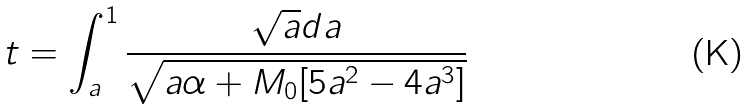<formula> <loc_0><loc_0><loc_500><loc_500>t = \int _ { a } ^ { 1 } \frac { \sqrt { a } d a } { \sqrt { a \alpha + M _ { 0 } [ 5 a ^ { 2 } - 4 a ^ { 3 } ] } }</formula> 